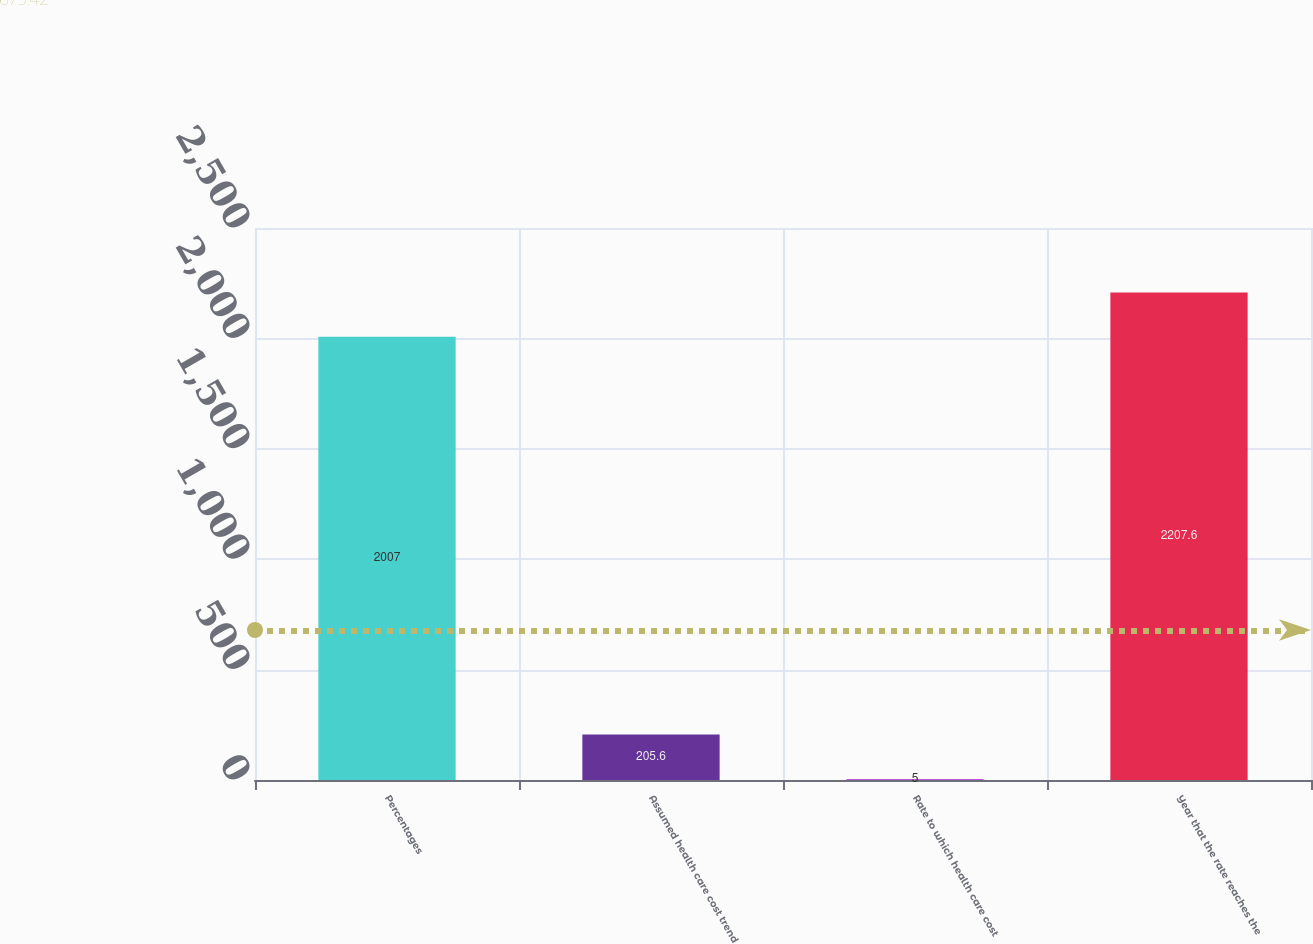Convert chart to OTSL. <chart><loc_0><loc_0><loc_500><loc_500><bar_chart><fcel>Percentages<fcel>Assumed health care cost trend<fcel>Rate to which health care cost<fcel>Year that the rate reaches the<nl><fcel>2007<fcel>205.6<fcel>5<fcel>2207.6<nl></chart> 